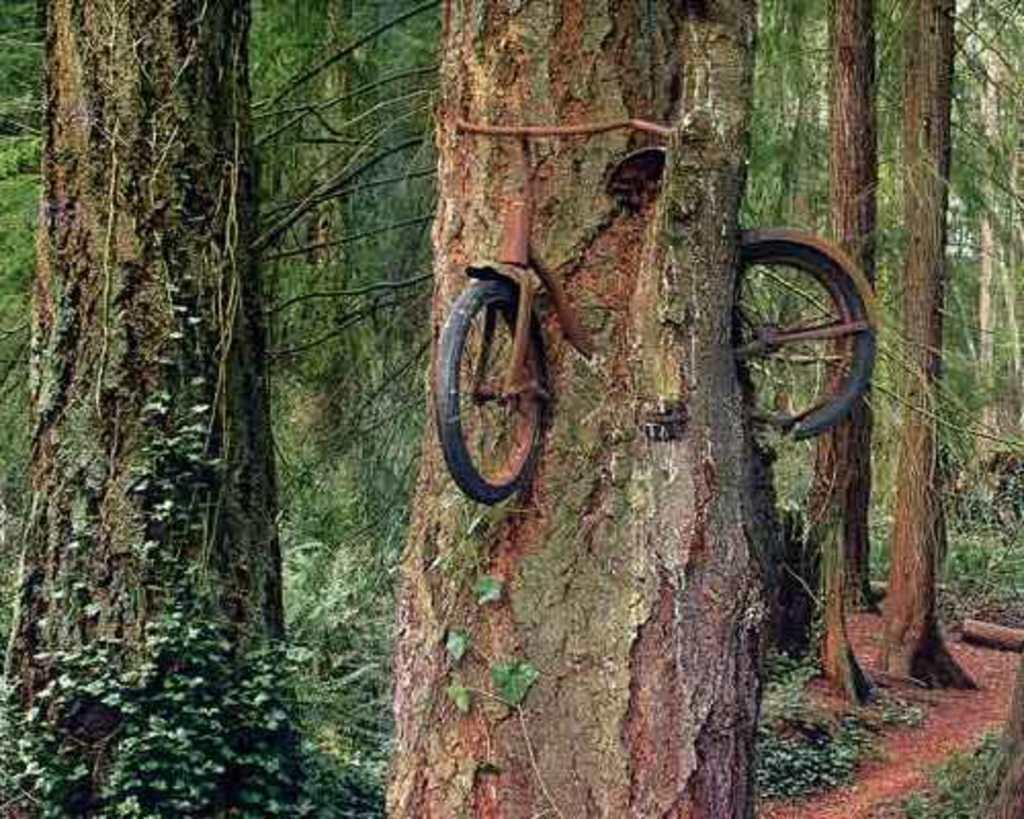In one or two sentences, can you explain what this image depicts? In this picture I can see a bicycle stuck into the tree trunk, and in the background there are trees. 